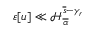Convert formula to latex. <formula><loc_0><loc_0><loc_500><loc_500>\varepsilon [ u ] \ll \mathcal { H } _ { \overline { \alpha } } ^ { \overline { s } - \gamma _ { r } }</formula> 